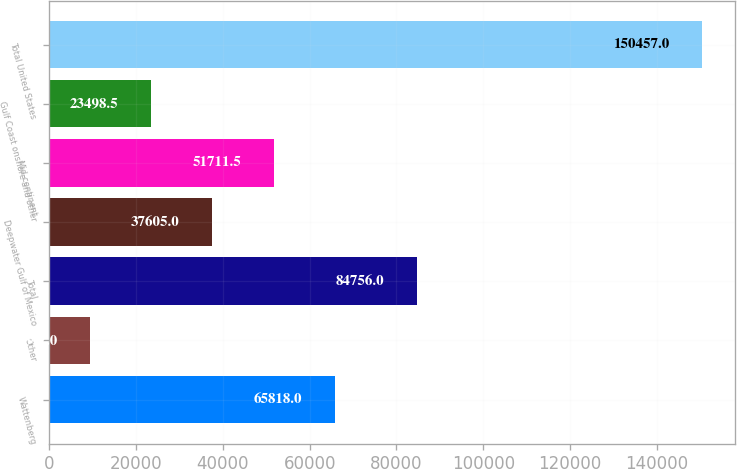Convert chart. <chart><loc_0><loc_0><loc_500><loc_500><bar_chart><fcel>Wattenberg<fcel>Other<fcel>Total<fcel>Deepwater Gulf of Mexico<fcel>Mid-continent<fcel>Gulf Coast onshore and other<fcel>Total United States<nl><fcel>65818<fcel>9392<fcel>84756<fcel>37605<fcel>51711.5<fcel>23498.5<fcel>150457<nl></chart> 